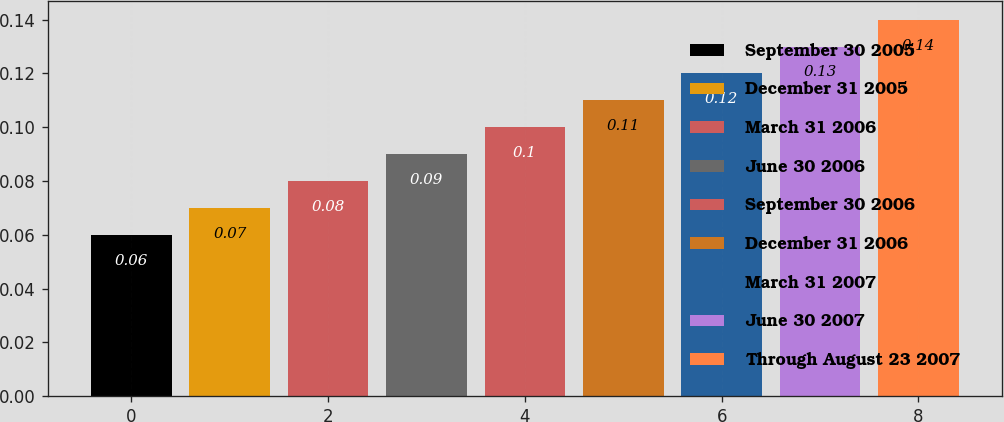<chart> <loc_0><loc_0><loc_500><loc_500><bar_chart><fcel>September 30 2005<fcel>December 31 2005<fcel>March 31 2006<fcel>June 30 2006<fcel>September 30 2006<fcel>December 31 2006<fcel>March 31 2007<fcel>June 30 2007<fcel>Through August 23 2007<nl><fcel>0.06<fcel>0.07<fcel>0.08<fcel>0.09<fcel>0.1<fcel>0.11<fcel>0.12<fcel>0.13<fcel>0.14<nl></chart> 